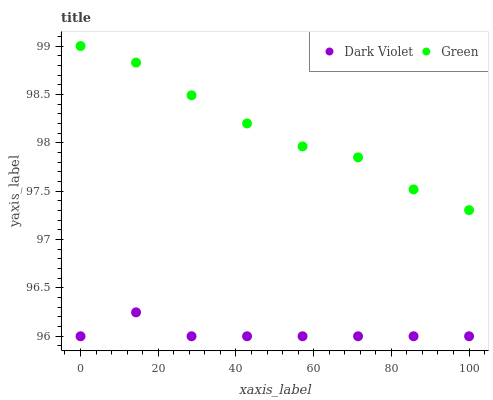Does Dark Violet have the minimum area under the curve?
Answer yes or no. Yes. Does Green have the maximum area under the curve?
Answer yes or no. Yes. Does Dark Violet have the maximum area under the curve?
Answer yes or no. No. Is Green the smoothest?
Answer yes or no. Yes. Is Dark Violet the roughest?
Answer yes or no. Yes. Is Dark Violet the smoothest?
Answer yes or no. No. Does Dark Violet have the lowest value?
Answer yes or no. Yes. Does Green have the highest value?
Answer yes or no. Yes. Does Dark Violet have the highest value?
Answer yes or no. No. Is Dark Violet less than Green?
Answer yes or no. Yes. Is Green greater than Dark Violet?
Answer yes or no. Yes. Does Dark Violet intersect Green?
Answer yes or no. No. 